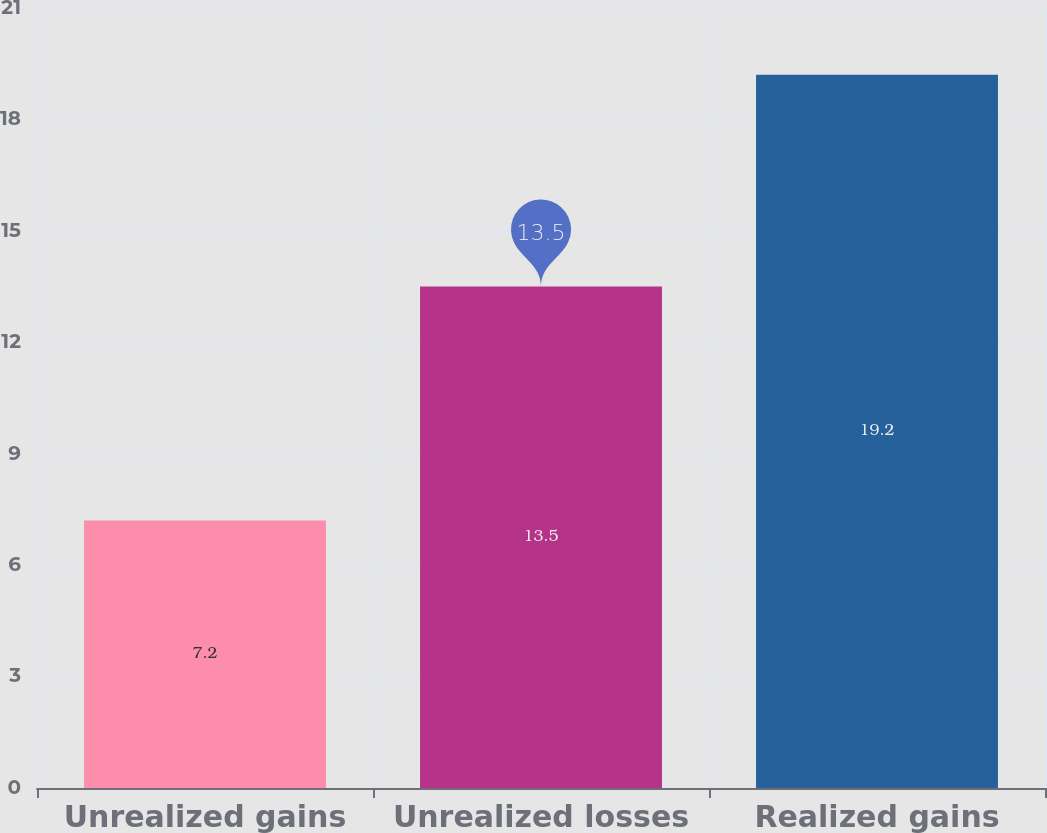Convert chart to OTSL. <chart><loc_0><loc_0><loc_500><loc_500><bar_chart><fcel>Unrealized gains<fcel>Unrealized losses<fcel>Realized gains<nl><fcel>7.2<fcel>13.5<fcel>19.2<nl></chart> 